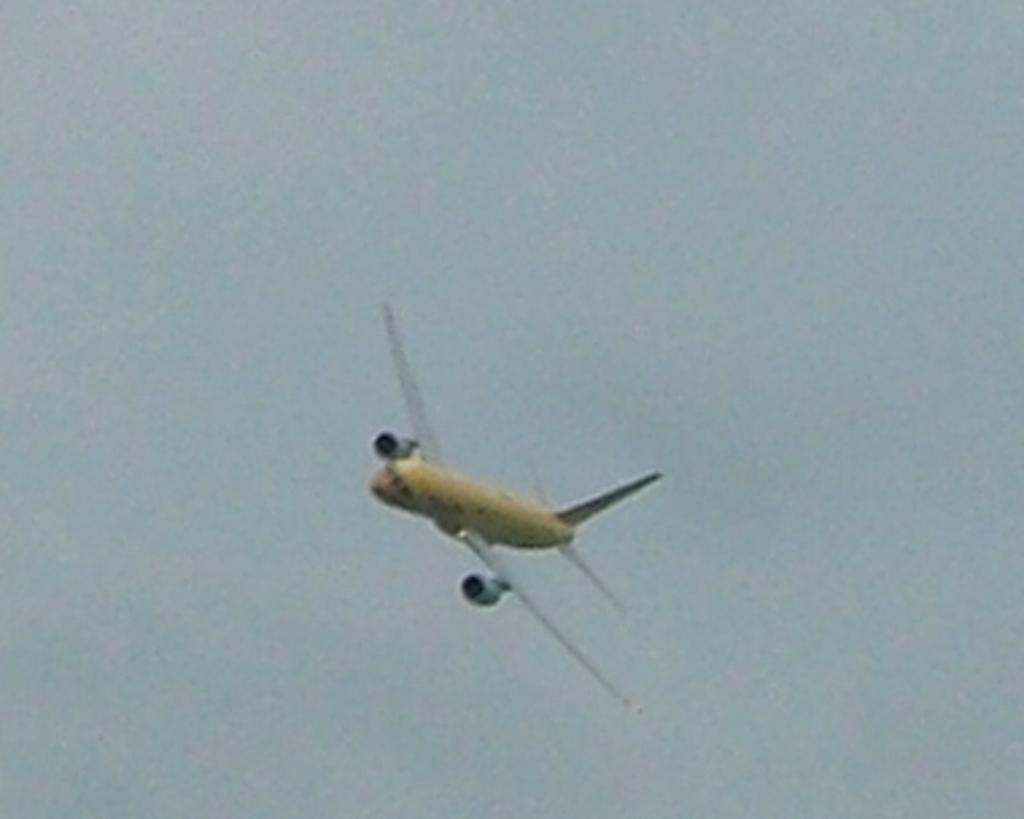What is happening in the image? There is a flight in the image. Where is the flight located? The flight is in the air. What can be seen in the background of the image? The sky is visible in the image. What reason does the flight have for taking a voyage in the image? There is no information about the flight's reason for taking a voyage in the image. How many seats are available on the flight in the image? There is no information about the number of seats on the flight in the image. 